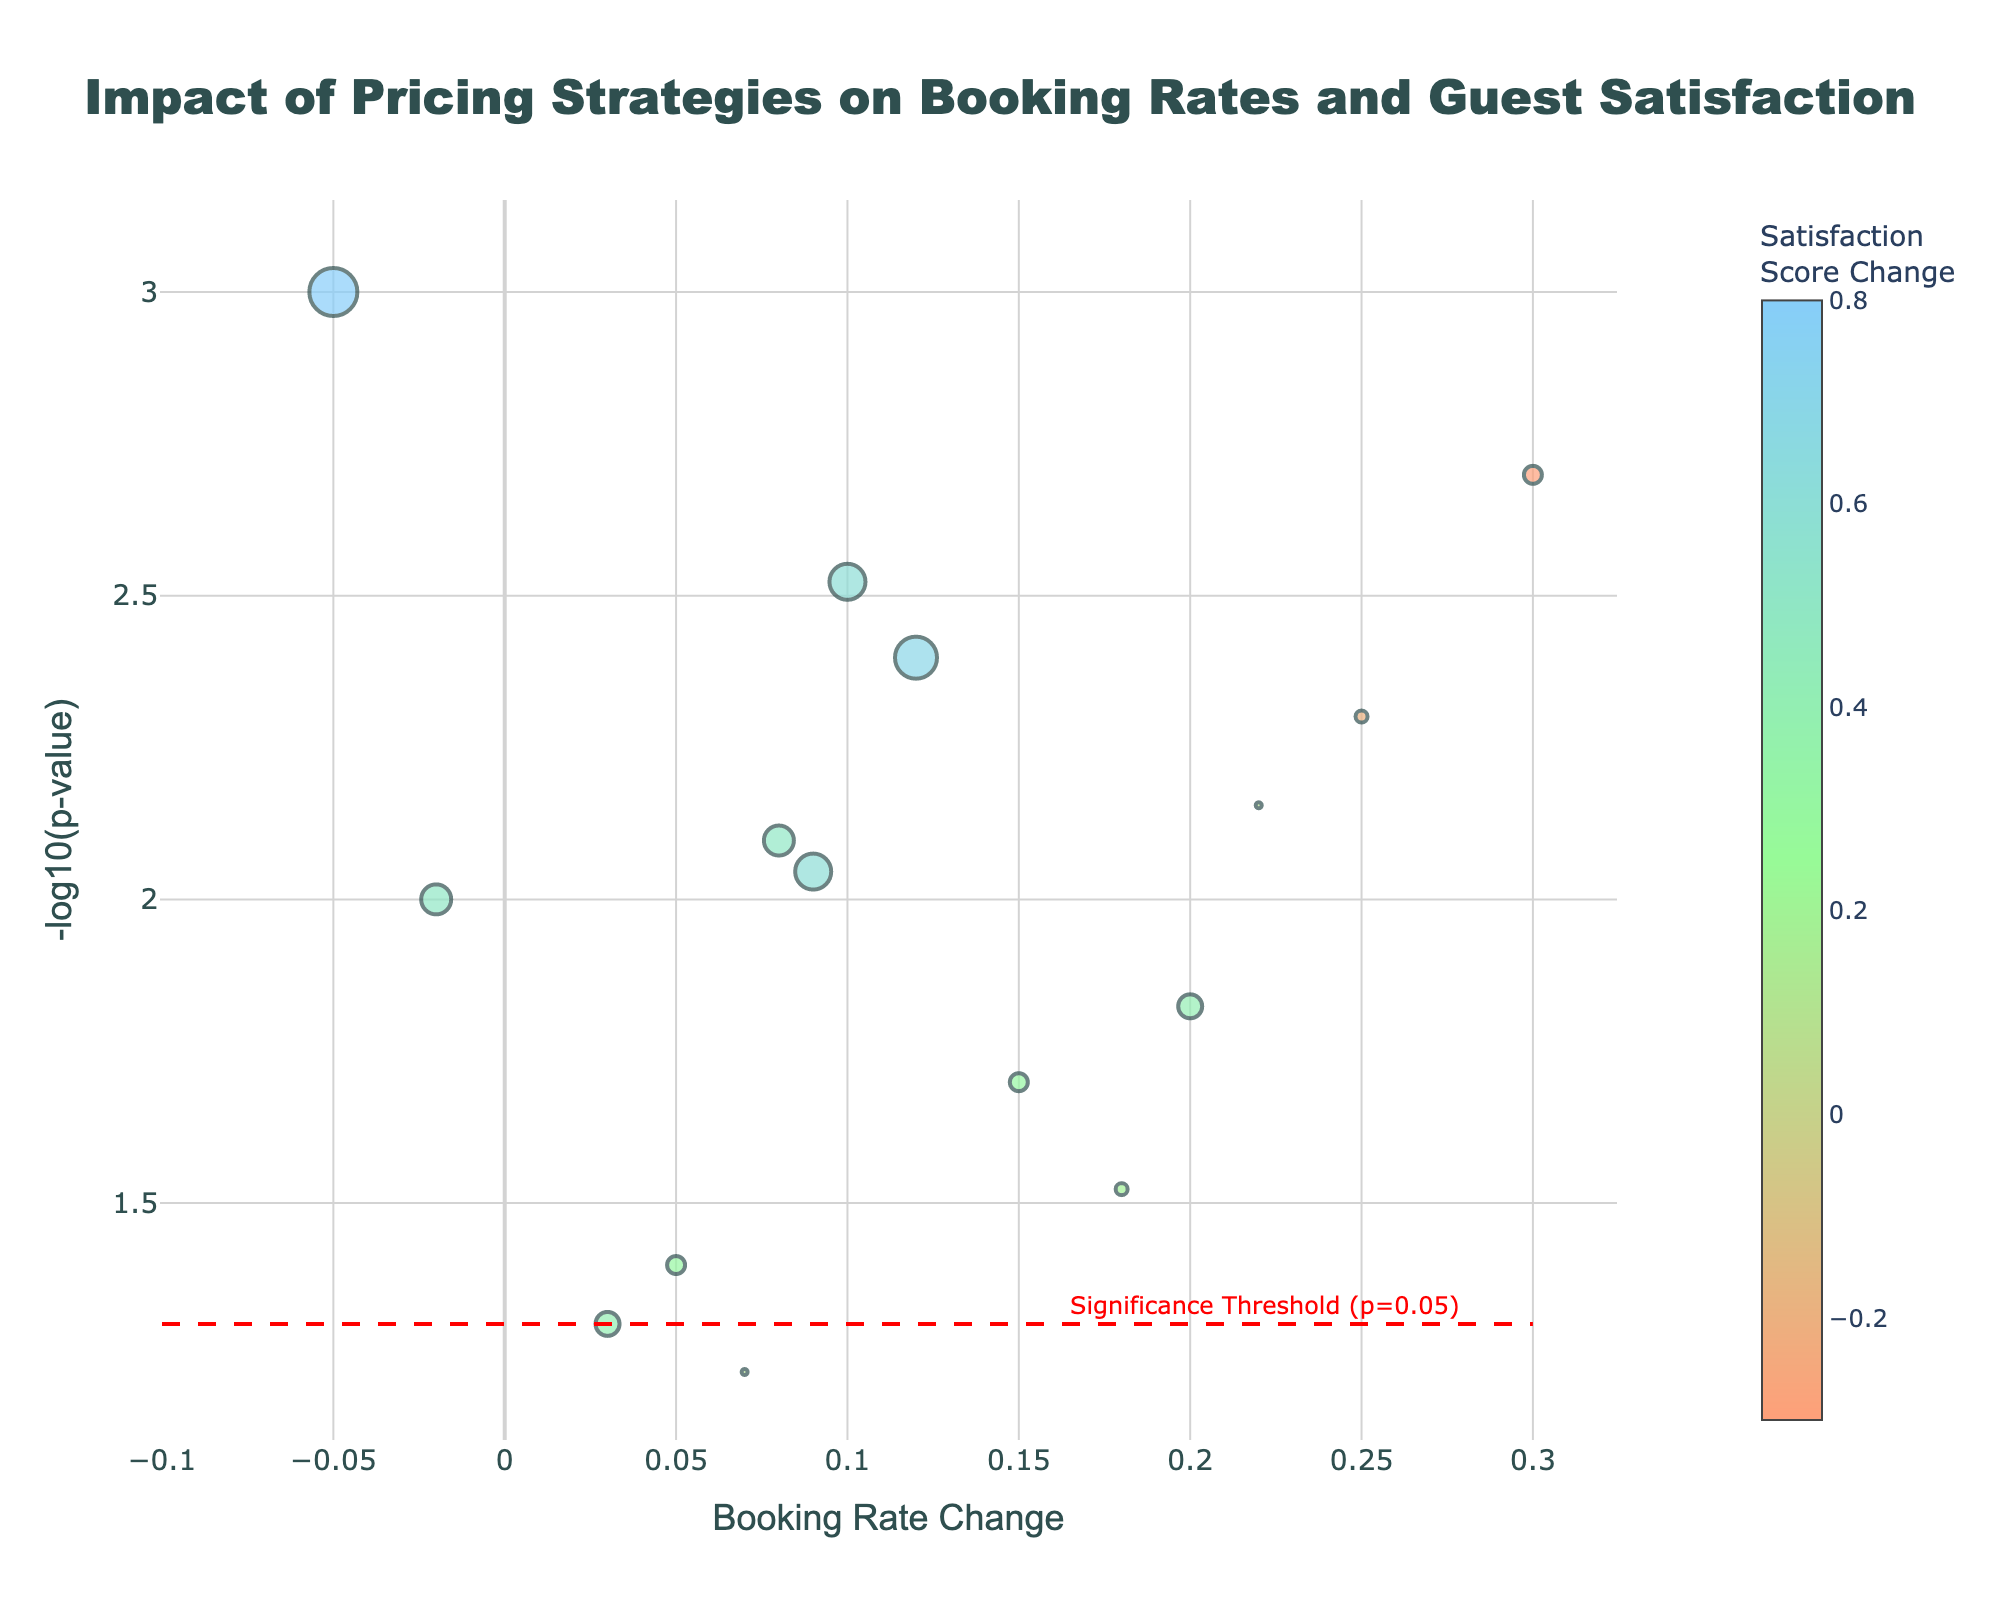Does the figure have a title? The figure's title is positioned at the top center, making it easy to identify.
Answer: Yes, the title is "Impact of Pricing Strategies on Booking Rates and Guest Satisfaction" Which axis represents the booking rate change? By looking at the figure, the horizontal (x) axis is labeled "Booking Rate Change".
Answer: The x-axis What does a larger bubble size indicate? Larger bubble sizes signify a greater absolute change in guest satisfaction scores.
Answer: Greater absolute change in satisfaction scores How many pricing strategies have a positive booking rate change? Counting the data points to the right of the vertical axis where booking rate change is more than 0, there are 11 strategies.
Answer: 11 strategies Which pricing strategy has the highest booking rate change? By identifying the point furthest to the right, "Flash sales" has the highest booking rate change.
Answer: Flash sales Of all the strategies, which has the smallest p-value? The smallest p-value corresponds to the highest position on the y-axis. "Dynamic pricing" has the highest -log10(p-value), hence the smallest p-value.
Answer: Dynamic pricing How many strategies have a p-value less than 0.05? Points above the threshold line (red dashed line) indicate a p-value less than 0.05. There are 12 such strategies.
Answer: 12 strategies Which pricing strategy has the most negative change in satisfaction score? The most negatively positioned point on the color scale indicates the strongest drop in satisfaction score. "Flash sales" has the most negative change.
Answer: Flash sales Do any strategies increase both booking rates and guest satisfaction? Points with both positive x values and positive bubble colors indicate increases in both metrics. There are seven such strategies.
Answer: Yes Which pricing strategy has a notable negative booking rate change with a very high satisfaction score change? "Dynamic pricing" stands out with negative booking rate change on the x-axis but a high position indicating significant satisfaction score change.
Answer: Dynamic pricing 